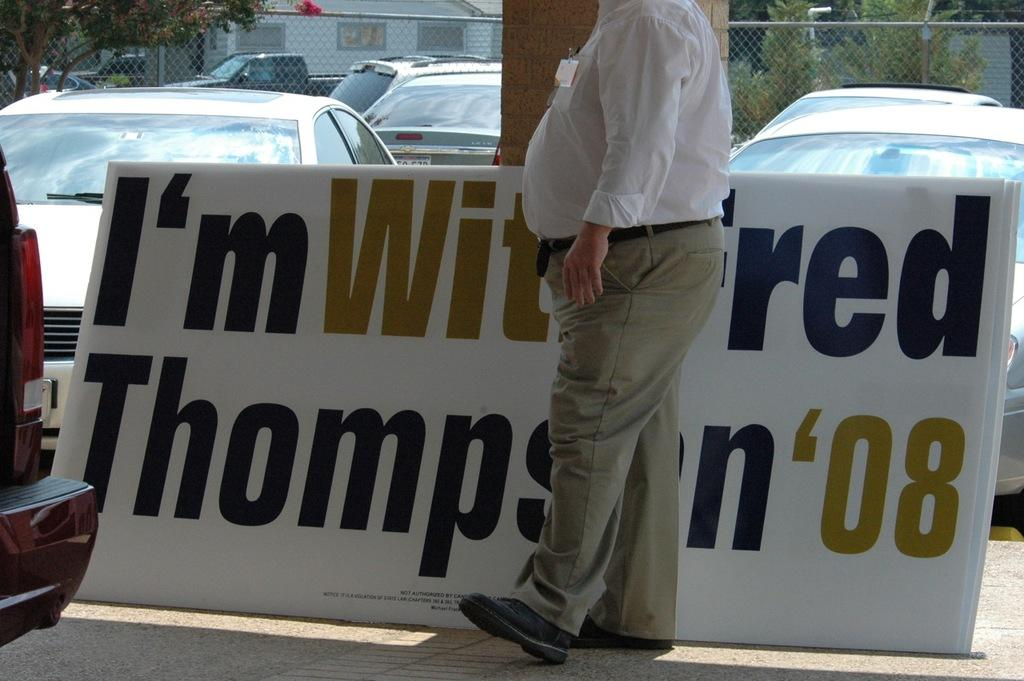What is the person standing near in the image? The person is standing near a hoarding. What else can be seen in the image besides the person and the hoarding? There are vehicles visible in the image. What is present at the top of the image? There is a mesh, trees, a house, and poles visible at the top of the image. Are there any other objects visible at the top of the image? Yes, there are other objects visible at the top of the image. How does the person in the image draw the attention of the sea? There is no sea present in the image, so the person cannot draw its attention. 